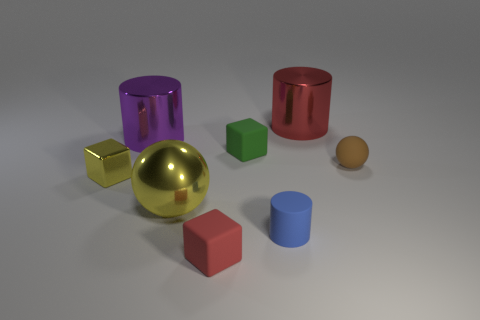Are there any big cylinders that are right of the small rubber block that is behind the blue rubber thing in front of the tiny yellow thing?
Offer a very short reply. Yes. Is there a yellow metal ball of the same size as the red cylinder?
Ensure brevity in your answer.  Yes. What is the material of the red thing that is the same size as the blue matte object?
Ensure brevity in your answer.  Rubber. There is a purple object; is it the same size as the yellow thing that is right of the small metal thing?
Ensure brevity in your answer.  Yes. How many metallic things are either large things or purple cylinders?
Your answer should be very brief. 3. How many big yellow metallic things have the same shape as the tiny brown thing?
Offer a terse response. 1. There is a object that is the same color as the small metallic block; what is it made of?
Provide a short and direct response. Metal. There is a red object that is on the right side of the small green block; is it the same size as the rubber block that is behind the metallic cube?
Your answer should be compact. No. What is the shape of the big metallic object that is in front of the purple cylinder?
Your answer should be compact. Sphere. There is a large purple thing that is the same shape as the large red metallic object; what material is it?
Ensure brevity in your answer.  Metal. 